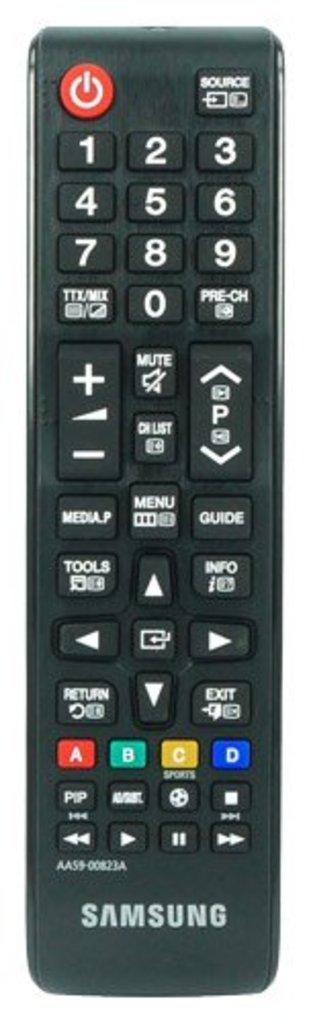<image>
Render a clear and concise summary of the photo. The long black remote control is labeled Samsung. 